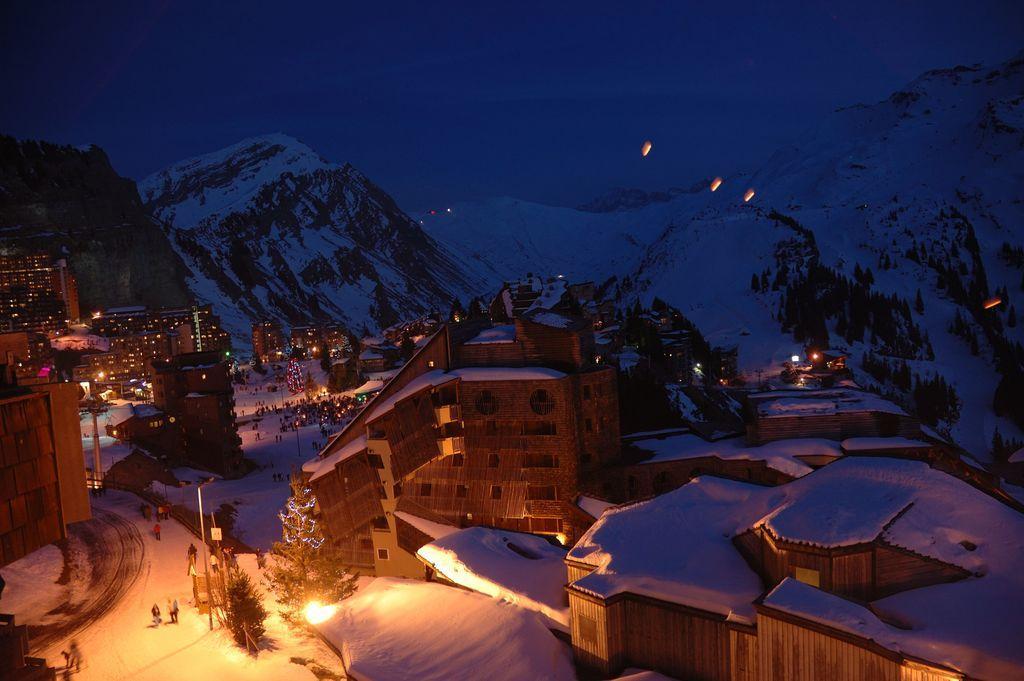Could you give a brief overview of what you see in this image? In this image there are some buildings in middle of this image and there are some mountains in the background and there is a sky on the top of this image and there are some persons standing on the bottom left side of this image and there is a tree in the bottom of this image. 